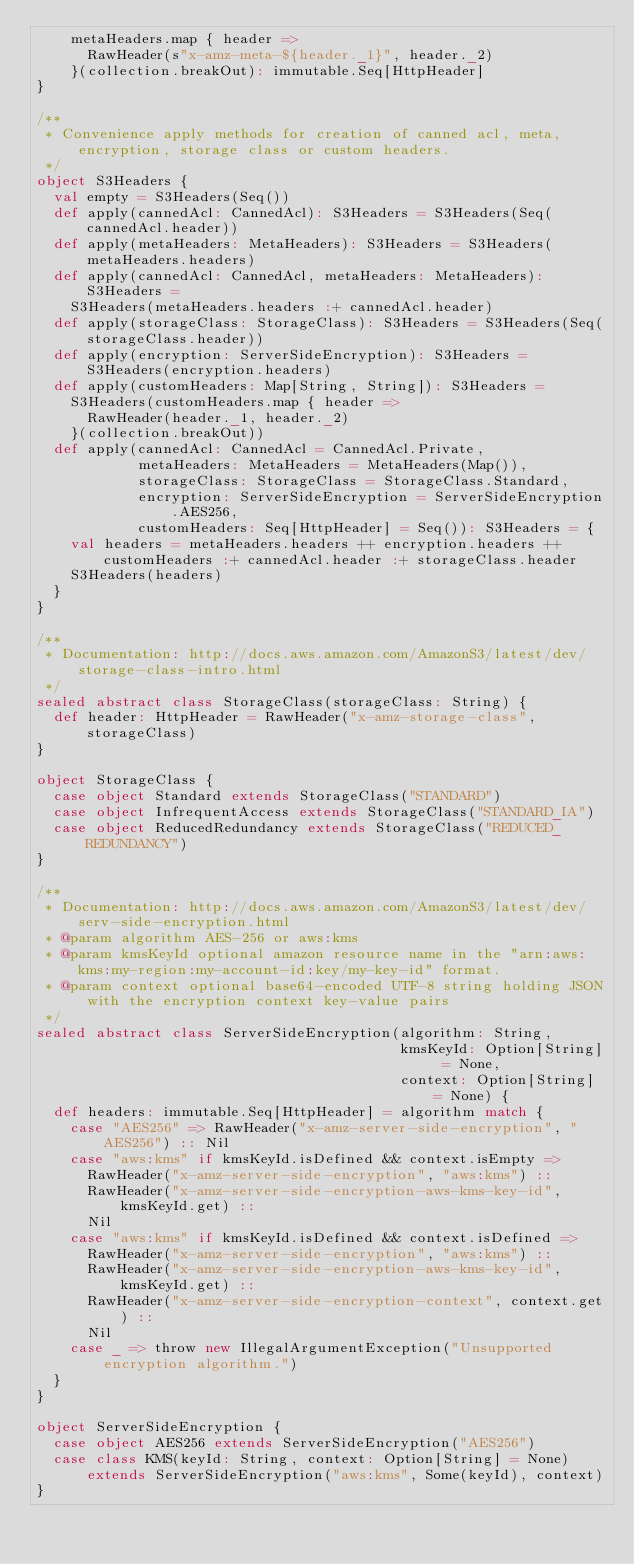Convert code to text. <code><loc_0><loc_0><loc_500><loc_500><_Scala_>    metaHeaders.map { header =>
      RawHeader(s"x-amz-meta-${header._1}", header._2)
    }(collection.breakOut): immutable.Seq[HttpHeader]
}

/**
 * Convenience apply methods for creation of canned acl, meta, encryption, storage class or custom headers.
 */
object S3Headers {
  val empty = S3Headers(Seq())
  def apply(cannedAcl: CannedAcl): S3Headers = S3Headers(Seq(cannedAcl.header))
  def apply(metaHeaders: MetaHeaders): S3Headers = S3Headers(metaHeaders.headers)
  def apply(cannedAcl: CannedAcl, metaHeaders: MetaHeaders): S3Headers =
    S3Headers(metaHeaders.headers :+ cannedAcl.header)
  def apply(storageClass: StorageClass): S3Headers = S3Headers(Seq(storageClass.header))
  def apply(encryption: ServerSideEncryption): S3Headers = S3Headers(encryption.headers)
  def apply(customHeaders: Map[String, String]): S3Headers =
    S3Headers(customHeaders.map { header =>
      RawHeader(header._1, header._2)
    }(collection.breakOut))
  def apply(cannedAcl: CannedAcl = CannedAcl.Private,
            metaHeaders: MetaHeaders = MetaHeaders(Map()),
            storageClass: StorageClass = StorageClass.Standard,
            encryption: ServerSideEncryption = ServerSideEncryption.AES256,
            customHeaders: Seq[HttpHeader] = Seq()): S3Headers = {
    val headers = metaHeaders.headers ++ encryption.headers ++ customHeaders :+ cannedAcl.header :+ storageClass.header
    S3Headers(headers)
  }
}

/**
 * Documentation: http://docs.aws.amazon.com/AmazonS3/latest/dev/storage-class-intro.html
 */
sealed abstract class StorageClass(storageClass: String) {
  def header: HttpHeader = RawHeader("x-amz-storage-class", storageClass)
}

object StorageClass {
  case object Standard extends StorageClass("STANDARD")
  case object InfrequentAccess extends StorageClass("STANDARD_IA")
  case object ReducedRedundancy extends StorageClass("REDUCED_REDUNDANCY")
}

/**
 * Documentation: http://docs.aws.amazon.com/AmazonS3/latest/dev/serv-side-encryption.html
 * @param algorithm AES-256 or aws:kms
 * @param kmsKeyId optional amazon resource name in the "arn:aws:kms:my-region:my-account-id:key/my-key-id" format.
 * @param context optional base64-encoded UTF-8 string holding JSON with the encryption context key-value pairs
 */
sealed abstract class ServerSideEncryption(algorithm: String,
                                           kmsKeyId: Option[String] = None,
                                           context: Option[String] = None) {
  def headers: immutable.Seq[HttpHeader] = algorithm match {
    case "AES256" => RawHeader("x-amz-server-side-encryption", "AES256") :: Nil
    case "aws:kms" if kmsKeyId.isDefined && context.isEmpty =>
      RawHeader("x-amz-server-side-encryption", "aws:kms") ::
      RawHeader("x-amz-server-side-encryption-aws-kms-key-id", kmsKeyId.get) ::
      Nil
    case "aws:kms" if kmsKeyId.isDefined && context.isDefined =>
      RawHeader("x-amz-server-side-encryption", "aws:kms") ::
      RawHeader("x-amz-server-side-encryption-aws-kms-key-id", kmsKeyId.get) ::
      RawHeader("x-amz-server-side-encryption-context", context.get) ::
      Nil
    case _ => throw new IllegalArgumentException("Unsupported encryption algorithm.")
  }
}

object ServerSideEncryption {
  case object AES256 extends ServerSideEncryption("AES256")
  case class KMS(keyId: String, context: Option[String] = None)
      extends ServerSideEncryption("aws:kms", Some(keyId), context)
}
</code> 